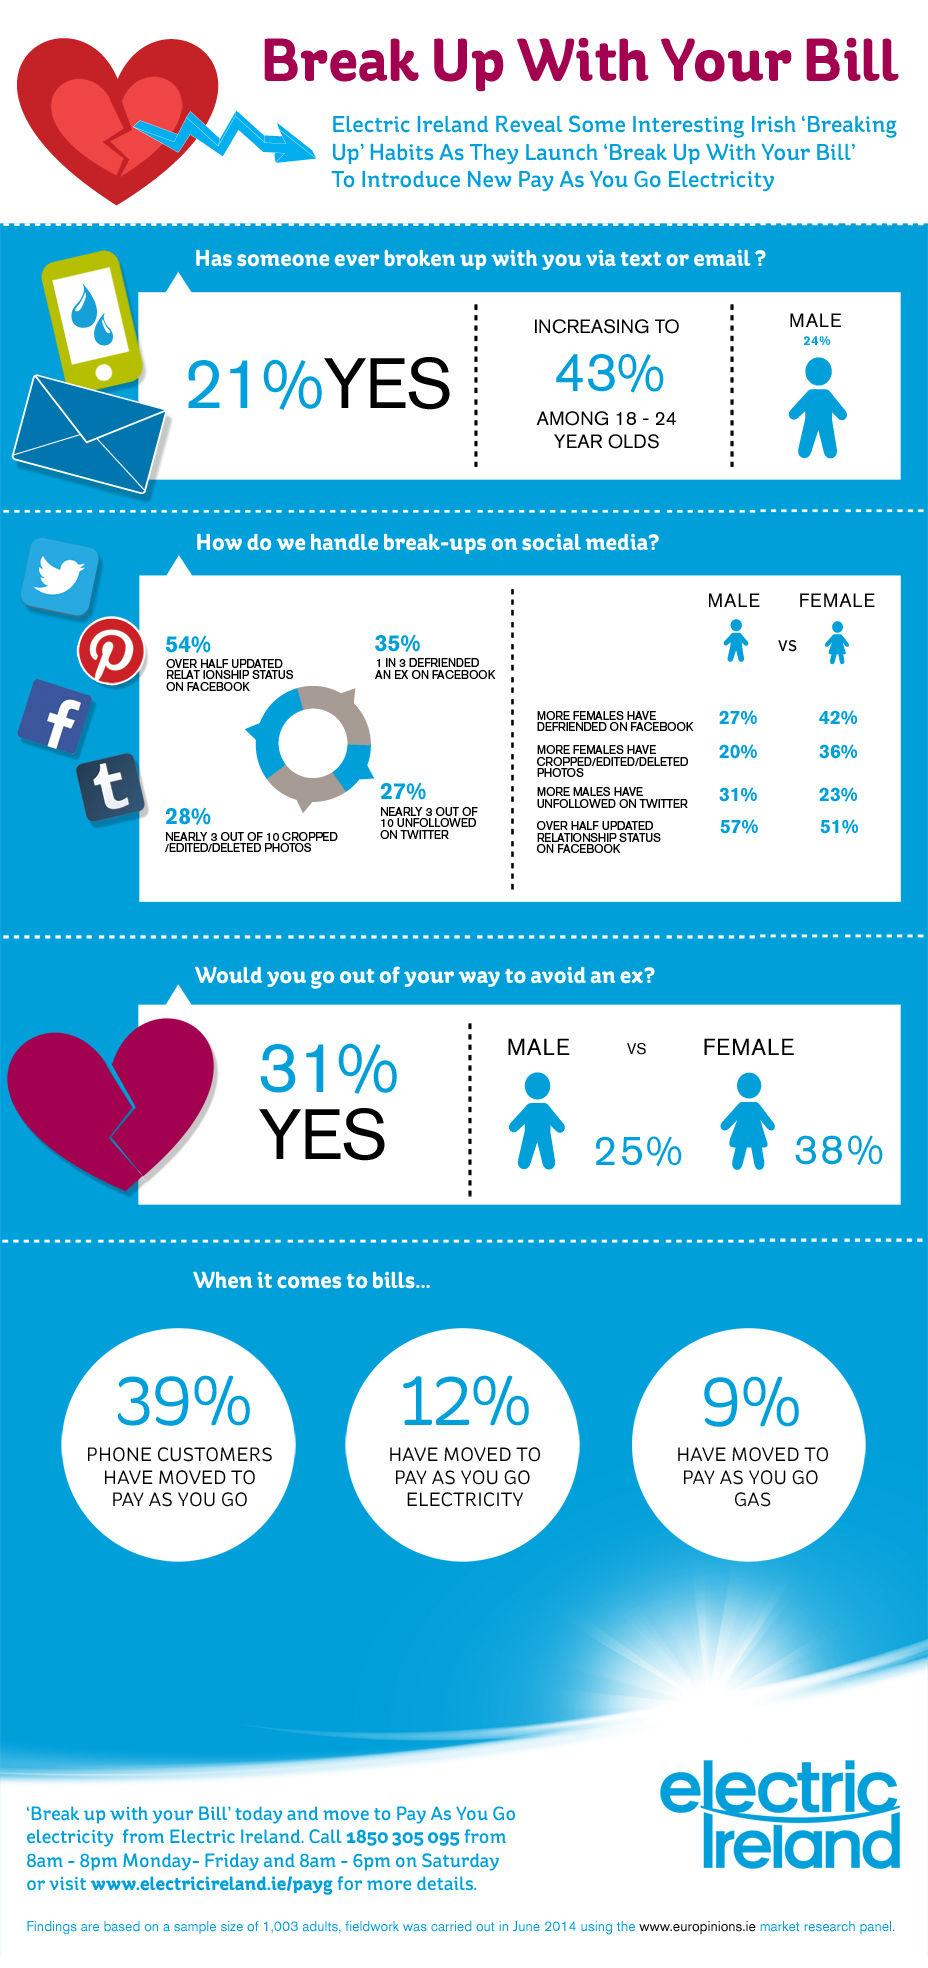Identify some key points in this picture. According to a survey, out of 10 people, 7 continue to follow their ex-partners on Twitter even after a break-up. A recent survey found that 28% of people have cropped, deleted, or edited photos on social media after a break-up. A significant majority of individuals, at 73%, continue to follow their ex-partner on Twitter even after a break-up. A female person may choose to go out more to avoid an ex-male person. Nine percent of people have switched to pay-as-you-go gas. 